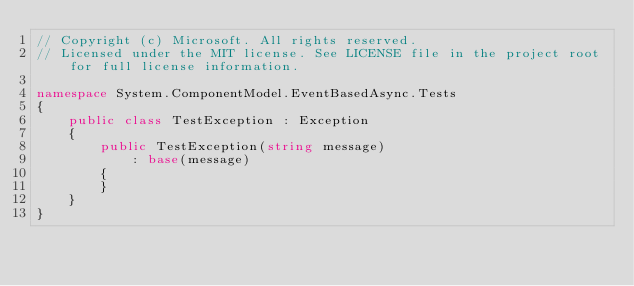<code> <loc_0><loc_0><loc_500><loc_500><_C#_>// Copyright (c) Microsoft. All rights reserved.
// Licensed under the MIT license. See LICENSE file in the project root for full license information.

namespace System.ComponentModel.EventBasedAsync.Tests
{
    public class TestException : Exception
    {
        public TestException(string message)
            : base(message)
        {
        }
    }
}
</code> 